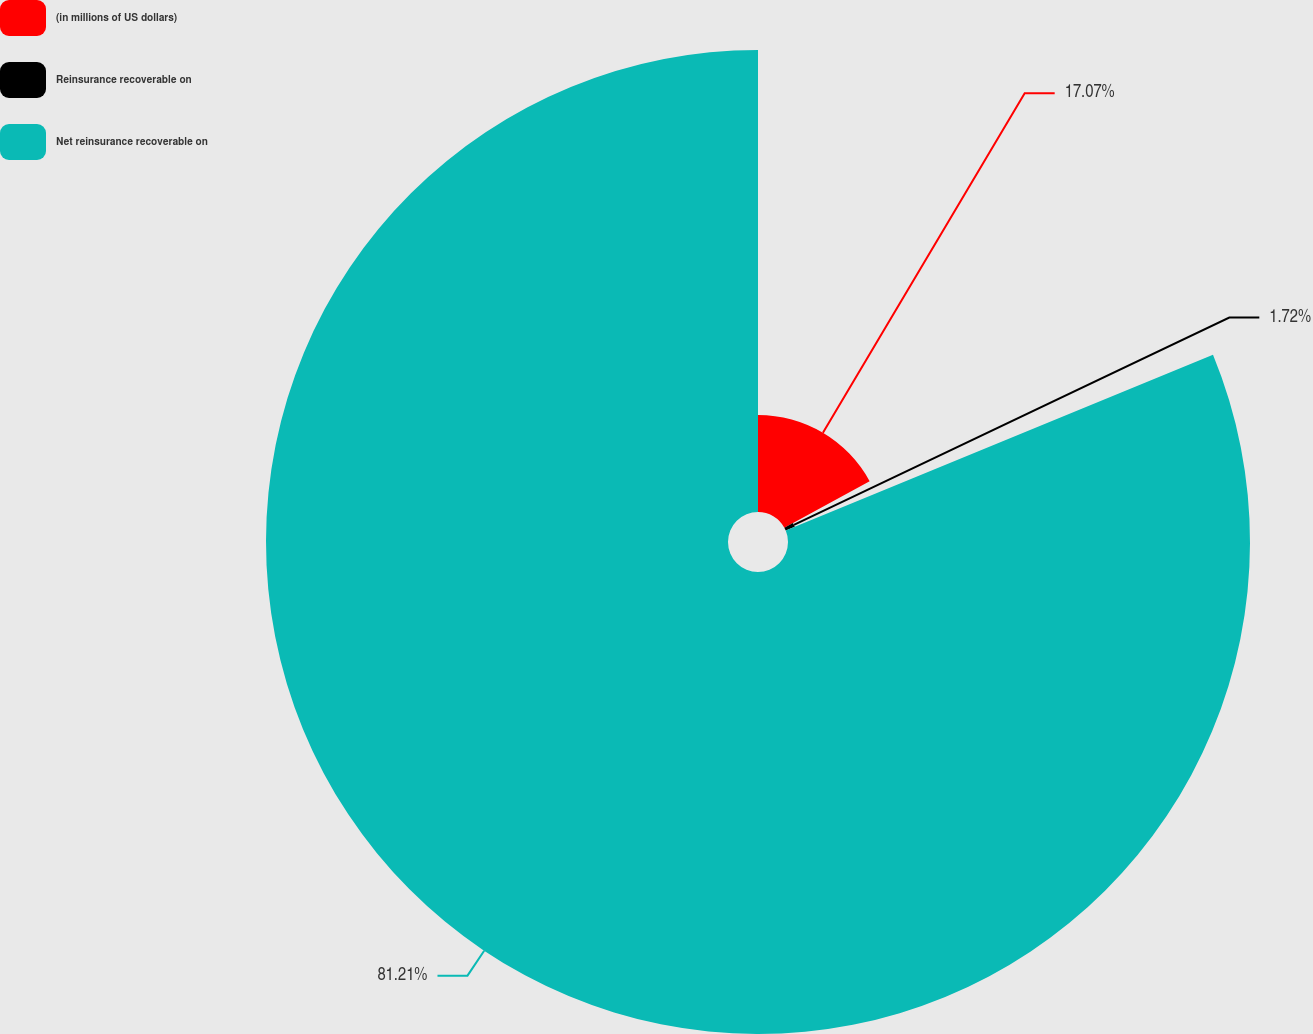Convert chart. <chart><loc_0><loc_0><loc_500><loc_500><pie_chart><fcel>(in millions of US dollars)<fcel>Reinsurance recoverable on<fcel>Net reinsurance recoverable on<nl><fcel>17.07%<fcel>1.72%<fcel>81.22%<nl></chart> 